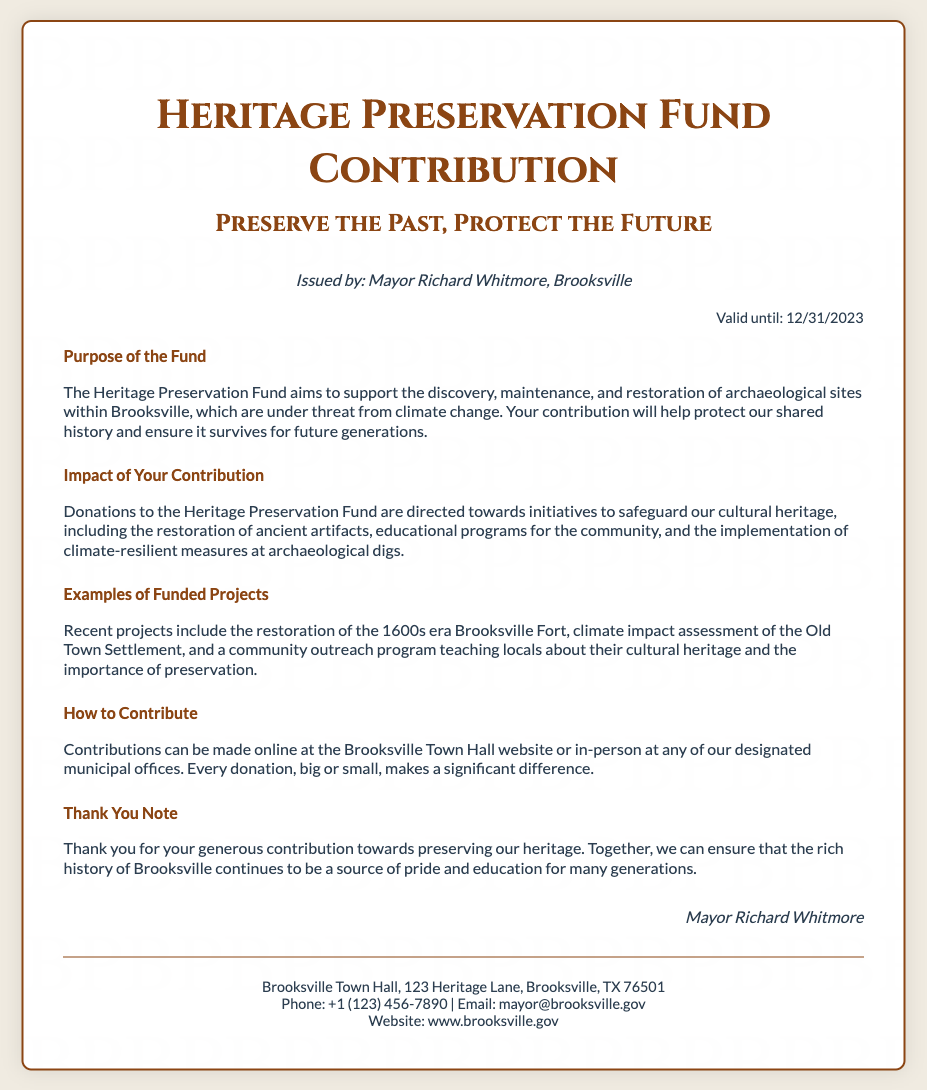what is the name of the fund? The fund is referred to as the "Heritage Preservation Fund" in the document.
Answer: Heritage Preservation Fund who issued the voucher? The document states that the voucher was issued by Mayor Richard Whitmore.
Answer: Mayor Richard Whitmore what is the expiration date of the voucher? The expiration date is clearly mentioned in the document.
Answer: 12/31/2023 what is the main purpose of the fund? The document outlines that the fund aims to support the discovery, maintenance, and restoration of archaeological sites.
Answer: Support discovery, maintenance, and restoration of archaeological sites name one recent project funded by the Heritage Preservation Fund. The document provides examples of funded projects, and one is the restoration of the 1600s era Brooksville Fort.
Answer: Restoration of the 1600s era Brooksville Fort how can contributions be made? The document explains that contributions can be made online or in-person at designated municipal offices.
Answer: Online or in-person at designated municipal offices what is the contact email provided in the document? The email address for contact is specifically mentioned at the bottom of the document.
Answer: mayor@brooksville.gov what is emphasized as the importance of your contribution? The document highlights that contributions will help safeguard cultural heritage, including educational programs.
Answer: Safeguard cultural heritage, including educational programs who is thanked for their contribution in the document? The document expresses thanks to the contributors towards preserving the heritage.
Answer: Contributors 